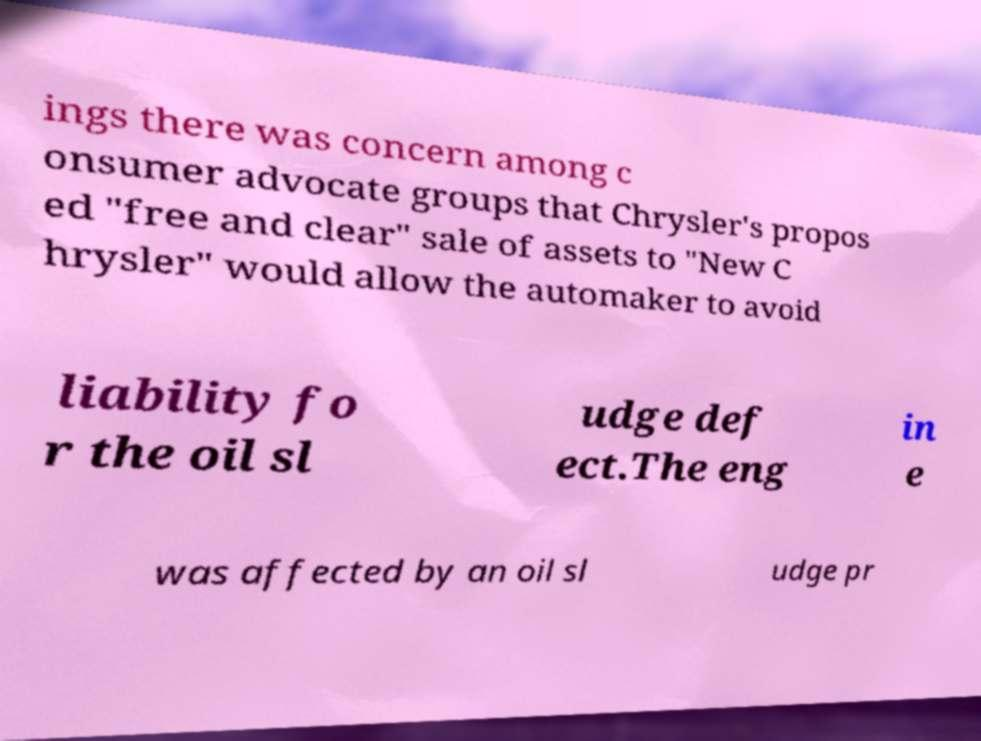For documentation purposes, I need the text within this image transcribed. Could you provide that? ings there was concern among c onsumer advocate groups that Chrysler's propos ed "free and clear" sale of assets to "New C hrysler" would allow the automaker to avoid liability fo r the oil sl udge def ect.The eng in e was affected by an oil sl udge pr 